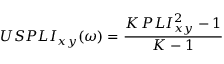<formula> <loc_0><loc_0><loc_500><loc_500>U S P L I _ { x y } ( \omega ) = \frac { K \, P L I _ { x y } ^ { 2 } - 1 } { K - 1 }</formula> 